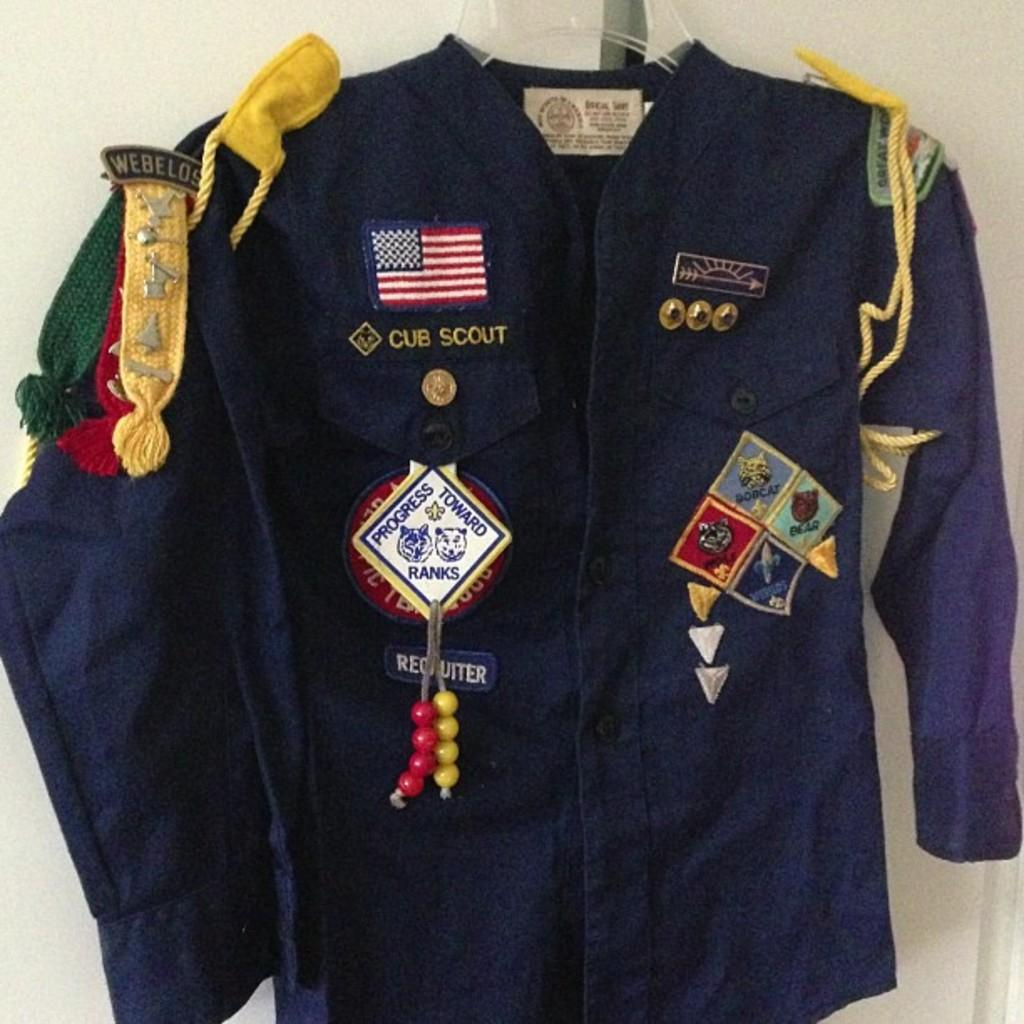Provide a one-sentence caption for the provided image. Cub Scout Shirt with many awards and with the United States Flag logo. 